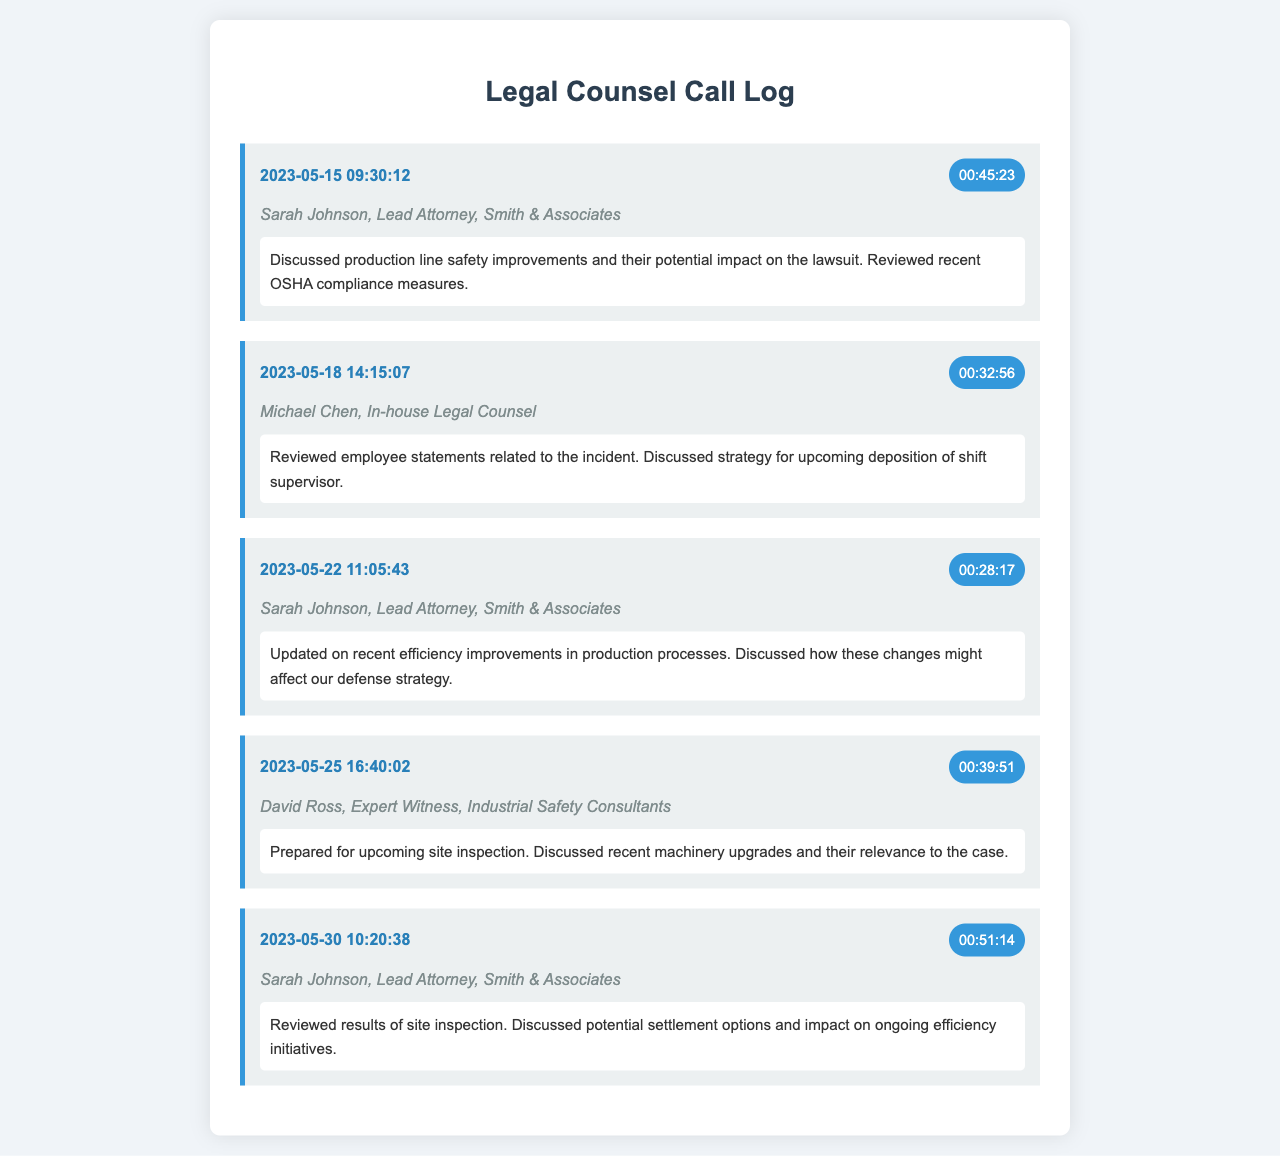What is the date of the longest call? The longest call is on 2023-05-30 with a duration of 51 minutes and 14 seconds.
Answer: 2023-05-30 Who had the first conversation in the log? The first conversation was with Sarah Johnson on May 15, 2023.
Answer: Sarah Johnson What is the duration of the call with David Ross? The call with David Ross lasted 39 minutes and 51 seconds.
Answer: 00:39:51 How many calls were made to Sarah Johnson? There are three calls made to Sarah Johnson in the call log.
Answer: 3 What was discussed in the call on May 22, 2023? The call on May 22 discussed efficiency improvements in production processes and their impact on defense strategy.
Answer: Efficiency improvements and defense strategy What was a key topic in the last call? The last call reviewed the results of a site inspection and discussed potential settlement options.
Answer: Site inspection and settlement options Who is the expert witness mentioned in the log? The expert witness mentioned in the log is David Ross.
Answer: David Ross What time was the call on May 18, 2023? The call on May 18, 2023, was at 14:15:07.
Answer: 14:15:07 What was the primary focus of the call on May 30, 2023? The primary focus was on reviewing the results of the site inspection and discussing settlement options.
Answer: Site inspection results and settlement options 